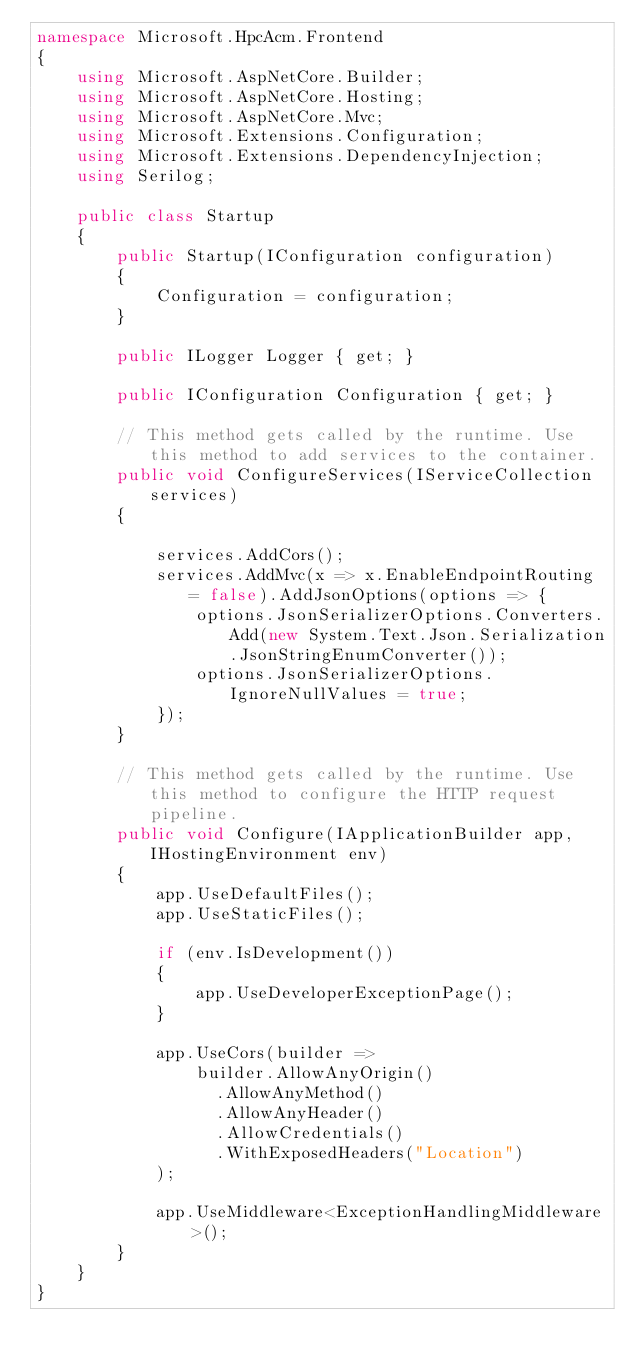<code> <loc_0><loc_0><loc_500><loc_500><_C#_>namespace Microsoft.HpcAcm.Frontend
{
    using Microsoft.AspNetCore.Builder;
    using Microsoft.AspNetCore.Hosting;
    using Microsoft.AspNetCore.Mvc;
    using Microsoft.Extensions.Configuration;
    using Microsoft.Extensions.DependencyInjection;
    using Serilog;

    public class Startup
    {
        public Startup(IConfiguration configuration)
        {
            Configuration = configuration;
        }

        public ILogger Logger { get; }

        public IConfiguration Configuration { get; }

        // This method gets called by the runtime. Use this method to add services to the container.
        public void ConfigureServices(IServiceCollection services)
        {
           
            services.AddCors();
            services.AddMvc(x => x.EnableEndpointRouting = false).AddJsonOptions(options => {
                options.JsonSerializerOptions.Converters.Add(new System.Text.Json.Serialization.JsonStringEnumConverter());
                options.JsonSerializerOptions.IgnoreNullValues = true;
            });
        }

        // This method gets called by the runtime. Use this method to configure the HTTP request pipeline.
        public void Configure(IApplicationBuilder app, IHostingEnvironment env)
        {
            app.UseDefaultFiles();
            app.UseStaticFiles();

            if (env.IsDevelopment())
            {
                app.UseDeveloperExceptionPage();
            }

            app.UseCors(builder =>
                builder.AllowAnyOrigin()
                  .AllowAnyMethod()
                  .AllowAnyHeader()
                  .AllowCredentials()
                  .WithExposedHeaders("Location")
            );

            app.UseMiddleware<ExceptionHandlingMiddleware>();
        }
    }
}
</code> 